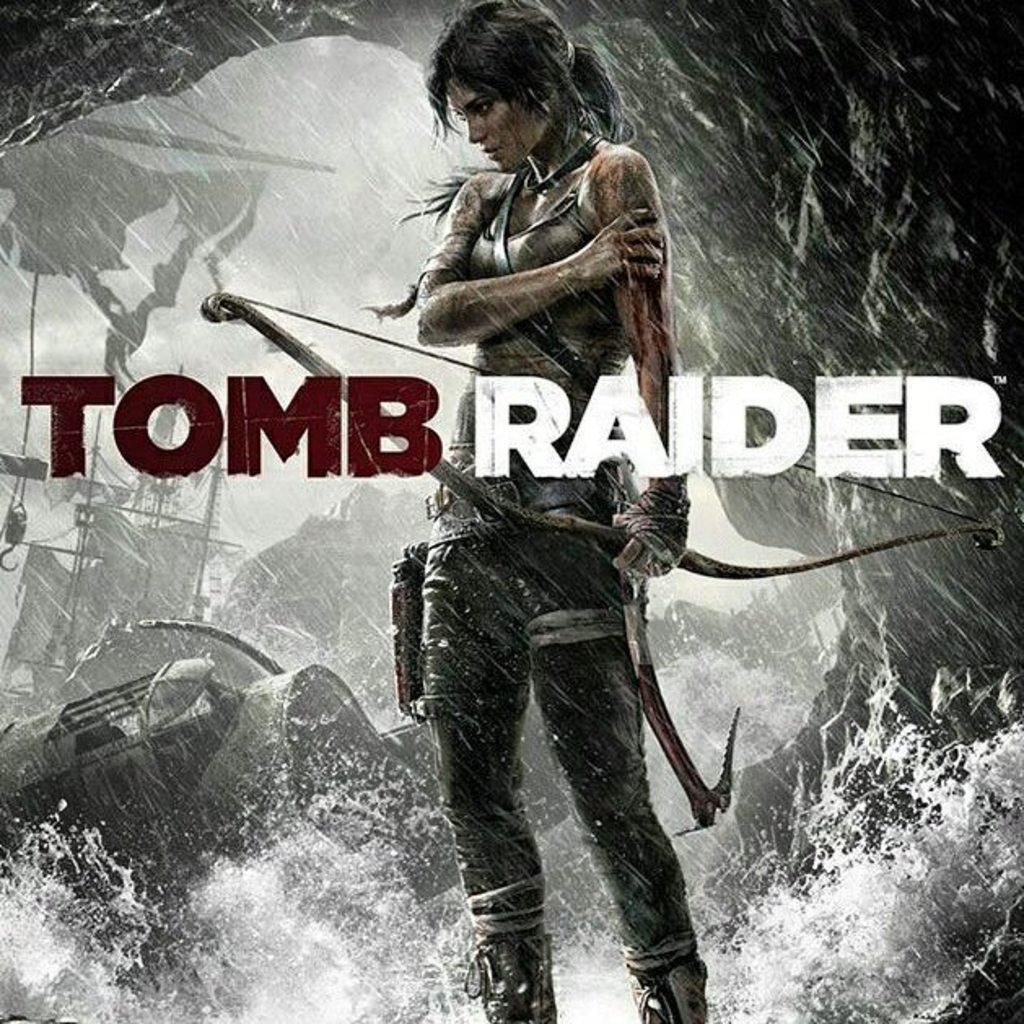What movie is this?
Ensure brevity in your answer.  Tomb raider. What is the first letter of the title?
Make the answer very short. T. 